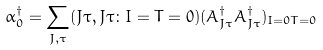Convert formula to latex. <formula><loc_0><loc_0><loc_500><loc_500>\alpha ^ { \dagger } _ { 0 } = \sum _ { J , \tau } ( J \tau , J \tau \colon I = T = 0 ) ( A ^ { \dagger } _ { J \tau } A ^ { \dagger } _ { J \tau } ) _ { I = 0 T = 0 }</formula> 